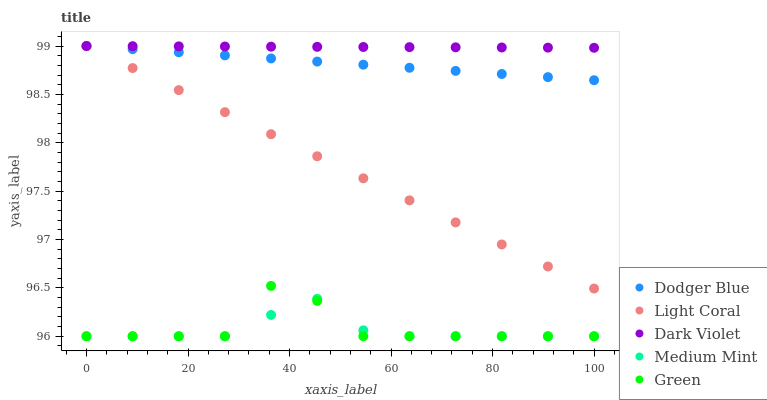Does Medium Mint have the minimum area under the curve?
Answer yes or no. Yes. Does Dark Violet have the maximum area under the curve?
Answer yes or no. Yes. Does Green have the minimum area under the curve?
Answer yes or no. No. Does Green have the maximum area under the curve?
Answer yes or no. No. Is Dodger Blue the smoothest?
Answer yes or no. Yes. Is Green the roughest?
Answer yes or no. Yes. Is Medium Mint the smoothest?
Answer yes or no. No. Is Medium Mint the roughest?
Answer yes or no. No. Does Medium Mint have the lowest value?
Answer yes or no. Yes. Does Dodger Blue have the lowest value?
Answer yes or no. No. Does Dark Violet have the highest value?
Answer yes or no. Yes. Does Green have the highest value?
Answer yes or no. No. Is Green less than Light Coral?
Answer yes or no. Yes. Is Light Coral greater than Green?
Answer yes or no. Yes. Does Dodger Blue intersect Dark Violet?
Answer yes or no. Yes. Is Dodger Blue less than Dark Violet?
Answer yes or no. No. Is Dodger Blue greater than Dark Violet?
Answer yes or no. No. Does Green intersect Light Coral?
Answer yes or no. No. 